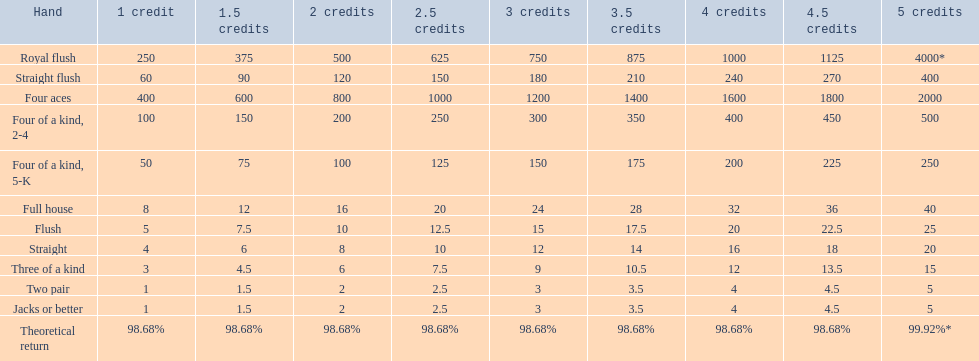What are the different hands? Royal flush, Straight flush, Four aces, Four of a kind, 2-4, Four of a kind, 5-K, Full house, Flush, Straight, Three of a kind, Two pair, Jacks or better. Which hands have a higher standing than a straight? Royal flush, Straight flush, Four aces, Four of a kind, 2-4, Four of a kind, 5-K, Full house, Flush. Of these, which hand is the next highest after a straight? Flush. 